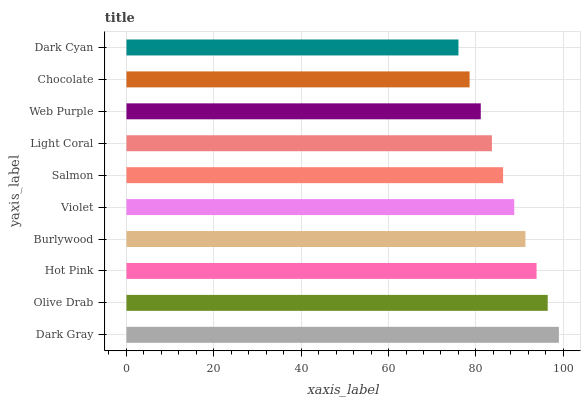Is Dark Cyan the minimum?
Answer yes or no. Yes. Is Dark Gray the maximum?
Answer yes or no. Yes. Is Olive Drab the minimum?
Answer yes or no. No. Is Olive Drab the maximum?
Answer yes or no. No. Is Dark Gray greater than Olive Drab?
Answer yes or no. Yes. Is Olive Drab less than Dark Gray?
Answer yes or no. Yes. Is Olive Drab greater than Dark Gray?
Answer yes or no. No. Is Dark Gray less than Olive Drab?
Answer yes or no. No. Is Violet the high median?
Answer yes or no. Yes. Is Salmon the low median?
Answer yes or no. Yes. Is Olive Drab the high median?
Answer yes or no. No. Is Hot Pink the low median?
Answer yes or no. No. 